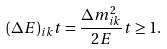Convert formula to latex. <formula><loc_0><loc_0><loc_500><loc_500>( \Delta E ) _ { i k } t = \frac { \Delta m ^ { 2 } _ { i k } } { 2 E } t \geq 1 .</formula> 